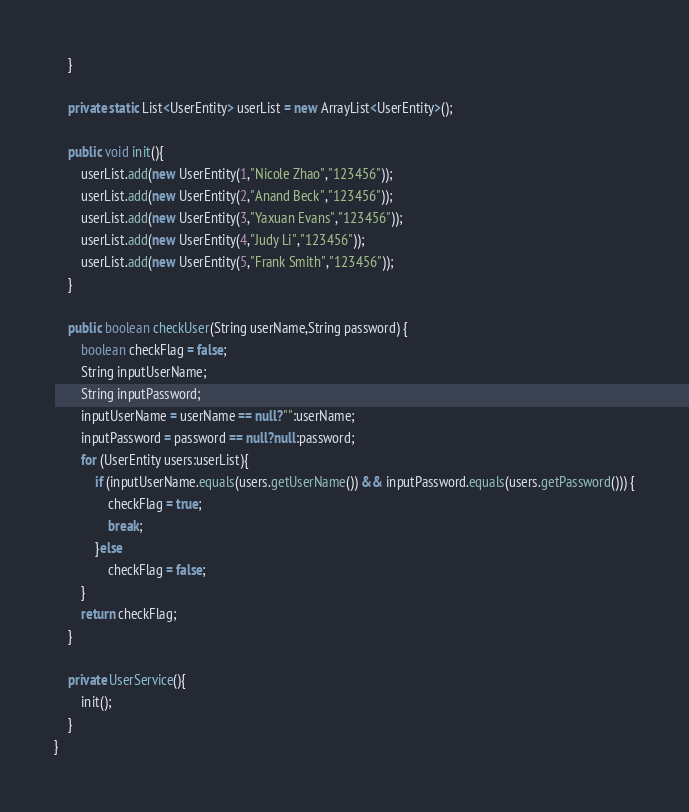Convert code to text. <code><loc_0><loc_0><loc_500><loc_500><_Java_>    }

    private static List<UserEntity> userList = new ArrayList<UserEntity>();

    public void init(){
        userList.add(new UserEntity(1,"Nicole Zhao","123456"));
        userList.add(new UserEntity(2,"Anand Beck","123456"));
        userList.add(new UserEntity(3,"Yaxuan Evans","123456"));
        userList.add(new UserEntity(4,"Judy Li","123456"));
        userList.add(new UserEntity(5,"Frank Smith","123456"));
    }

    public boolean checkUser(String userName,String password) {
        boolean checkFlag = false;
        String inputUserName;
        String inputPassword;
        inputUserName = userName == null?"":userName;
        inputPassword = password == null?null:password;
        for (UserEntity users:userList){
            if (inputUserName.equals(users.getUserName()) && inputPassword.equals(users.getPassword())) {
                checkFlag = true;
                break;
            }else
                checkFlag = false;
        }
        return checkFlag;
    }

    private UserService(){
        init();
    }
}
</code> 